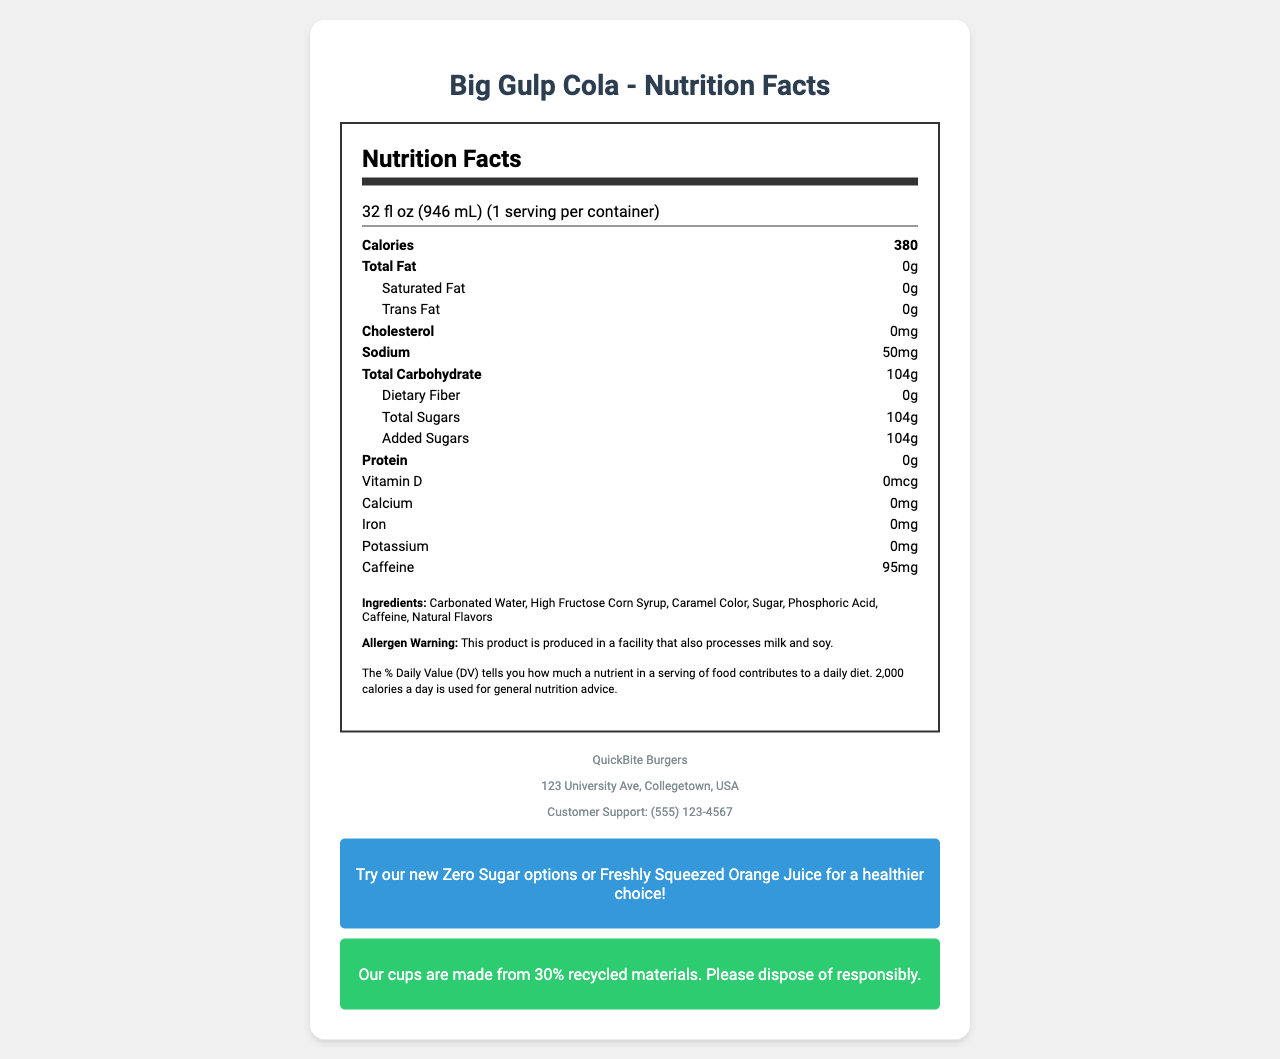what is the serving size of the Big Gulp Cola? The serving size information is listed at the top of the nutrition facts label.
Answer: 32 fl oz (946 mL) how many calories are in one serving of Big Gulp Cola? The calories per serving are clearly mentioned in the "Calories" row within the nutrition label.
Answer: 380 how much sodium is in one serving? The sodium content per serving is specified in the "Sodium" row.
Answer: 50mg what is the amount of total sugars per serving? The total sugars per serving are listed in the sub-nutrient section under "Total Carbohydrate".
Answer: 104g does Big Gulp Cola contain any protein? The protein content is mentioned as 0g in the nutrient rows.
Answer: No, 0g which ingredient is listed first? The ingredients are listed in the order they are found in the drink, with "Carbonated Water" being the first.
Answer: Carbonated Water what is one way to reduce sugar intake mentioned in the document? This is mentioned in the promotion section at the bottom of the document.
Answer: Try our new Zero Sugar options or Freshly Squeezed Orange Juice how many caffeine milligrams are in one serving? The caffeine content per serving is listed in the nutrient rows.
Answer: 95mg which of the following ingredients is not in Big Gulp Cola? A. High Fructose Corn Syrup B. Caramel Color C. Vitamin C D. Natural Flavors Vitamin C is not listed among the ingredients for Big Gulp Cola.
Answer: C. Vitamin C how much cholesterol does Big Gulp Cola contain per serving? A. 0mg B. 10mg C. 20mg D. 50mg The cholesterol content is listed as 0mg in the nutrient rows.
Answer: A. 0mg true or false: Big Gulp Cola contains dietary fiber. The dietary fiber content is listed as 0g in the sub-nutrient section under "Total Carbohydrate".
Answer: False provide a summary of the key nutrition facts for Big Gulp Cola The summary captures the essential nutritional and ingredient information presented visually on the document.
Answer: Big Gulp Cola has a serving size of 32 fl oz, contains 380 calories per serving, no fat or protein, 50mg sodium, 104g total carbohydrates with all of it coming from sugars, and 95mg of caffeine. It contains ingredients like Carbonated Water and High Fructose Corn Syrup. what are the environmental benefits of using the Big Gulp Cola cups? This information is found in the sustainability section.
Answer: Cups are made from 30% recycled materials, and it encourages responsible disposal. what might be a match for the customer support contact number? The customer support phone number is listed in the franchise-specific information section.
Answer: (555) 123-4567 how much is the total fat per serving? The total fat content is listed as 0g in the nutrient rows.
Answer: 0g where is the QuickBite Burgers franchise located? The franchise location address is given in the franchise-specific information section.
Answer: 123 University Ave, Collegetown, USA how many servings per container are there? The servings per container are clearly mentioned in the serving info section.
Answer: 1 how many grams of saturated fat are in a serving of Big Gulp Cola? The saturated fat content per serving is listed as 0g in the sub-nutrient section under "Total Fat".
Answer: 0g how healthy is Big Gulp Cola in terms of added sugars? The added sugars content is shown clearly in the sub-nutrient section under "Total Carbohydrate".
Answer: It contains 104g of added sugars per serving, which is very high. what vitamin and mineral content does Big Gulp Cola provide? The vitamin and mineral content is detailed in the nutrient rows.
Answer: 0mcg Vitamin D, 0mg Calcium, 0mg Iron, and 0mg Potassium how are customers informed about potential allergens? The allergen warning information is given in the ingredients section.
Answer: Allergen warning: This product is produced in a facility that also processes milk and soy. how many ingredients are listed for Big Gulp Cola? The ingredients listed are Carbonated Water, High Fructose Corn Syrup, Caramel Color, Sugar, Phosphoric Acid, Caffeine, and Natural Flavors.
Answer: 7 ingredients what is the average daily value based on for the nutrition facts provided? This information is provided in the daily value footnote.
Answer: 2,000 calories a day 